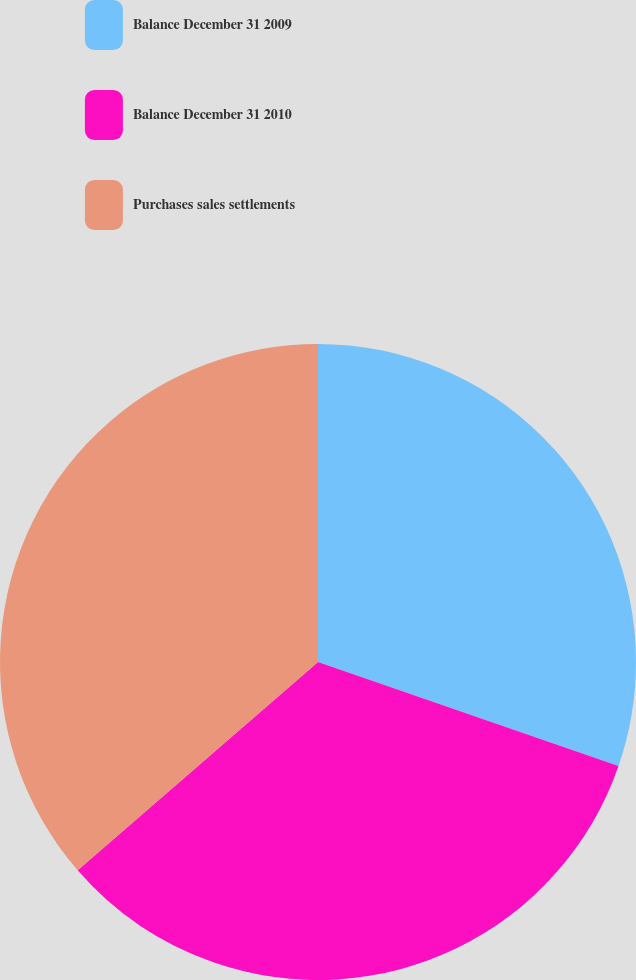Convert chart to OTSL. <chart><loc_0><loc_0><loc_500><loc_500><pie_chart><fcel>Balance December 31 2009<fcel>Balance December 31 2010<fcel>Purchases sales settlements<nl><fcel>30.3%<fcel>33.33%<fcel>36.36%<nl></chart> 